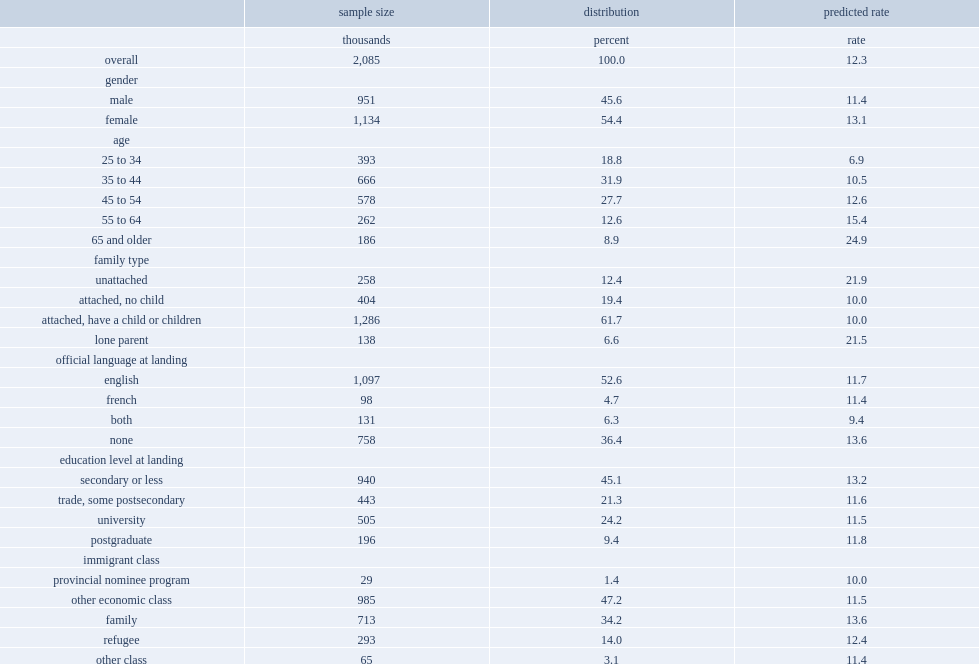What was the multiple relationship between immigrant seniors aged 65 and older and immigrants aged 25 to 34? 3.608696. What was the adjusted rate among the longer-tenured immigrants(16 to 20 years) ? 9.5. What was the multiple relationship between immigrants with no knowledge of english or french and immigrants with knowledge of both languages? 1.446809. What was the multiple relationship between immigrants with a secondary school education and those with a non-university postsecondary education? 1.118644. 